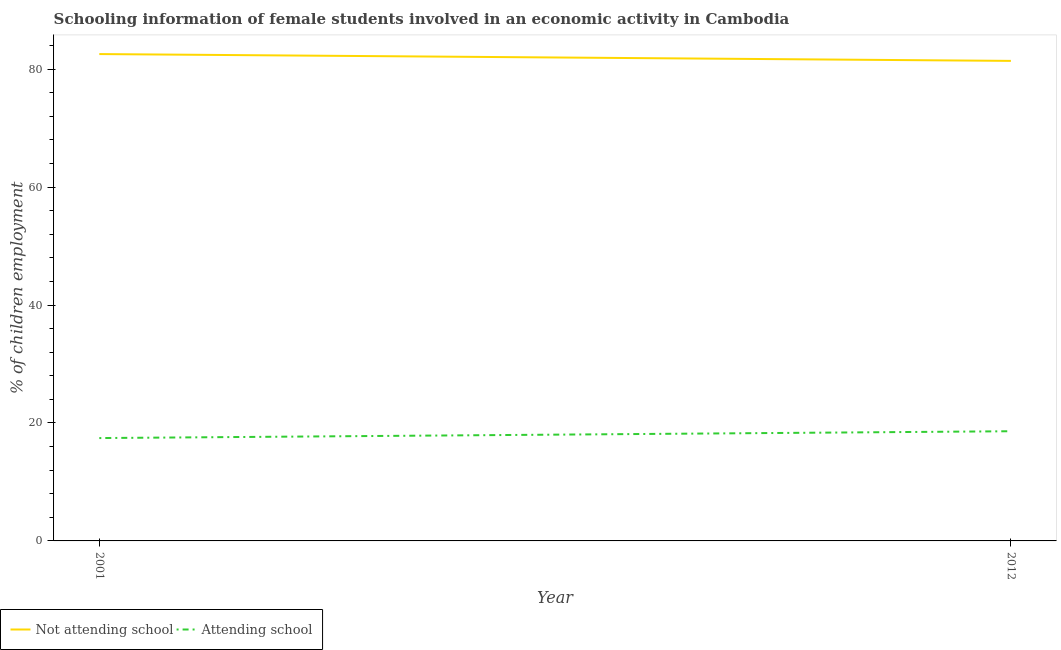How many different coloured lines are there?
Your answer should be very brief. 2. Does the line corresponding to percentage of employed females who are not attending school intersect with the line corresponding to percentage of employed females who are attending school?
Your response must be concise. No. Is the number of lines equal to the number of legend labels?
Give a very brief answer. Yes. What is the percentage of employed females who are not attending school in 2012?
Offer a very short reply. 81.4. Across all years, what is the maximum percentage of employed females who are not attending school?
Ensure brevity in your answer.  82.56. Across all years, what is the minimum percentage of employed females who are not attending school?
Offer a very short reply. 81.4. In which year was the percentage of employed females who are not attending school maximum?
Your response must be concise. 2001. What is the total percentage of employed females who are not attending school in the graph?
Give a very brief answer. 163.96. What is the difference between the percentage of employed females who are not attending school in 2001 and that in 2012?
Your response must be concise. 1.16. What is the difference between the percentage of employed females who are attending school in 2012 and the percentage of employed females who are not attending school in 2001?
Give a very brief answer. -63.96. What is the average percentage of employed females who are attending school per year?
Make the answer very short. 18.02. In the year 2001, what is the difference between the percentage of employed females who are not attending school and percentage of employed females who are attending school?
Provide a short and direct response. 65.12. What is the ratio of the percentage of employed females who are attending school in 2001 to that in 2012?
Ensure brevity in your answer.  0.94. In how many years, is the percentage of employed females who are not attending school greater than the average percentage of employed females who are not attending school taken over all years?
Keep it short and to the point. 1. Is the percentage of employed females who are not attending school strictly less than the percentage of employed females who are attending school over the years?
Give a very brief answer. No. Does the graph contain any zero values?
Ensure brevity in your answer.  No. How many legend labels are there?
Your answer should be compact. 2. How are the legend labels stacked?
Your answer should be very brief. Horizontal. What is the title of the graph?
Your response must be concise. Schooling information of female students involved in an economic activity in Cambodia. Does "Boys" appear as one of the legend labels in the graph?
Your response must be concise. No. What is the label or title of the X-axis?
Your answer should be compact. Year. What is the label or title of the Y-axis?
Keep it short and to the point. % of children employment. What is the % of children employment in Not attending school in 2001?
Your answer should be compact. 82.56. What is the % of children employment in Attending school in 2001?
Your answer should be compact. 17.44. What is the % of children employment in Not attending school in 2012?
Give a very brief answer. 81.4. What is the % of children employment in Attending school in 2012?
Your response must be concise. 18.6. Across all years, what is the maximum % of children employment in Not attending school?
Your answer should be compact. 82.56. Across all years, what is the minimum % of children employment of Not attending school?
Provide a succinct answer. 81.4. Across all years, what is the minimum % of children employment in Attending school?
Provide a short and direct response. 17.44. What is the total % of children employment in Not attending school in the graph?
Your response must be concise. 163.96. What is the total % of children employment of Attending school in the graph?
Offer a very short reply. 36.04. What is the difference between the % of children employment of Not attending school in 2001 and that in 2012?
Make the answer very short. 1.16. What is the difference between the % of children employment of Attending school in 2001 and that in 2012?
Keep it short and to the point. -1.16. What is the difference between the % of children employment in Not attending school in 2001 and the % of children employment in Attending school in 2012?
Offer a very short reply. 63.96. What is the average % of children employment in Not attending school per year?
Ensure brevity in your answer.  81.98. What is the average % of children employment of Attending school per year?
Make the answer very short. 18.02. In the year 2001, what is the difference between the % of children employment in Not attending school and % of children employment in Attending school?
Give a very brief answer. 65.12. In the year 2012, what is the difference between the % of children employment of Not attending school and % of children employment of Attending school?
Make the answer very short. 62.8. What is the ratio of the % of children employment of Not attending school in 2001 to that in 2012?
Your response must be concise. 1.01. What is the ratio of the % of children employment of Attending school in 2001 to that in 2012?
Provide a succinct answer. 0.94. What is the difference between the highest and the second highest % of children employment of Not attending school?
Offer a very short reply. 1.16. What is the difference between the highest and the second highest % of children employment in Attending school?
Your answer should be compact. 1.16. What is the difference between the highest and the lowest % of children employment in Not attending school?
Keep it short and to the point. 1.16. What is the difference between the highest and the lowest % of children employment of Attending school?
Your response must be concise. 1.16. 